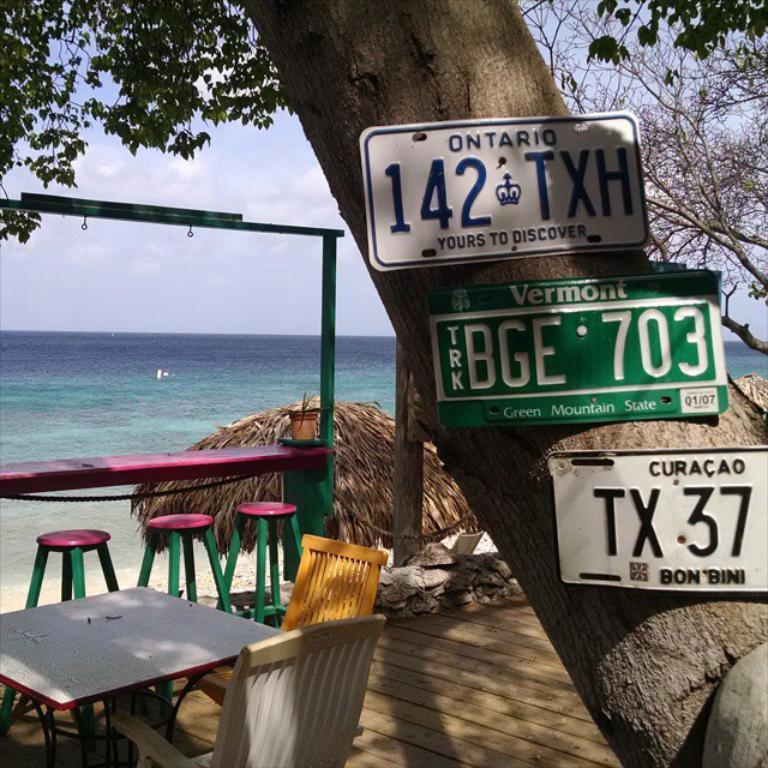Could you give a brief overview of what you see in this image? This is the image with the 3 number plates that are fixed to the tree and the left side of the tree there are 3 chairs, a table , a jar , another table and 2 chairs and umbrella and at the back ground there is a beach , sky covered with clouds. 